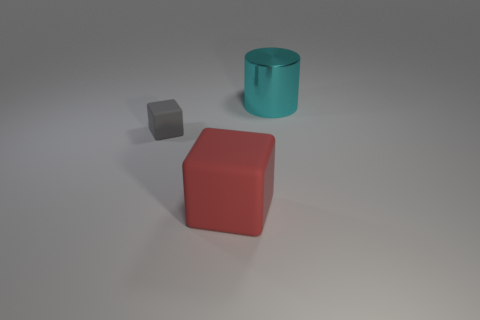Add 1 big green shiny things. How many objects exist? 4 Subtract all red blocks. How many blocks are left? 1 Subtract 1 blocks. How many blocks are left? 1 Subtract all green cylinders. How many red blocks are left? 1 Subtract all cyan cylinders. Subtract all small matte objects. How many objects are left? 1 Add 3 tiny matte cubes. How many tiny matte cubes are left? 4 Add 3 small gray cubes. How many small gray cubes exist? 4 Subtract 0 cyan balls. How many objects are left? 3 Subtract all blocks. How many objects are left? 1 Subtract all purple cylinders. Subtract all gray blocks. How many cylinders are left? 1 